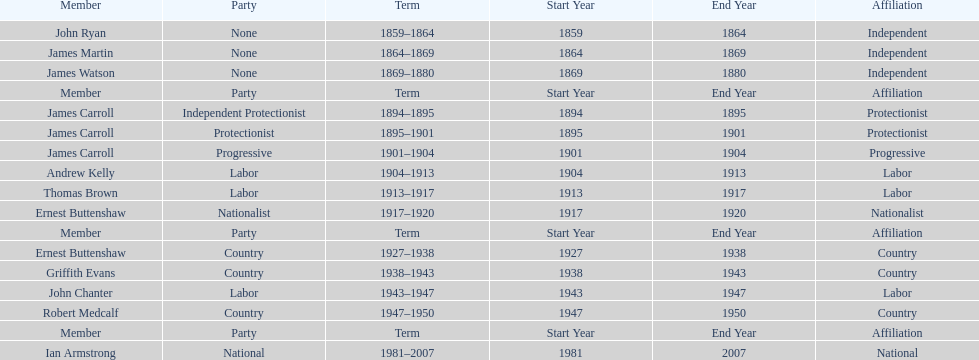Could you parse the entire table? {'header': ['Member', 'Party', 'Term', 'Start Year', 'End Year', 'Affiliation'], 'rows': [['John Ryan', 'None', '1859–1864', '1859', '1864', 'Independent'], ['James Martin', 'None', '1864–1869', '1864', '1869', 'Independent'], ['James Watson', 'None', '1869–1880', '1869', '1880', 'Independent'], ['Member', 'Party', 'Term', 'Start Year', 'End Year', 'Affiliation'], ['James Carroll', 'Independent Protectionist', '1894–1895', '1894', '1895', 'Protectionist'], ['James Carroll', 'Protectionist', '1895–1901', '1895', '1901', 'Protectionist'], ['James Carroll', 'Progressive', '1901–1904', '1901', '1904', 'Progressive'], ['Andrew Kelly', 'Labor', '1904–1913', '1904', '1913', 'Labor'], ['Thomas Brown', 'Labor', '1913–1917', '1913', '1917', 'Labor'], ['Ernest Buttenshaw', 'Nationalist', '1917–1920', '1917', '1920', 'Nationalist'], ['Member', 'Party', 'Term', 'Start Year', 'End Year', 'Affiliation'], ['Ernest Buttenshaw', 'Country', '1927–1938', '1927', '1938', 'Country'], ['Griffith Evans', 'Country', '1938–1943', '1938', '1943', 'Country'], ['John Chanter', 'Labor', '1943–1947', '1943', '1947', 'Labor'], ['Robert Medcalf', 'Country', '1947–1950', '1947', '1950', 'Country'], ['Member', 'Party', 'Term', 'Start Year', 'End Year', 'Affiliation'], ['Ian Armstrong', 'National', '1981–2007', '1981', '2007', 'National']]} How many years of service do the members of the second incarnation have combined? 26. 